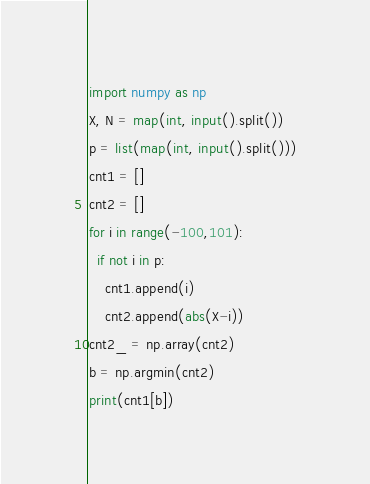<code> <loc_0><loc_0><loc_500><loc_500><_Python_>import numpy as np
X, N = map(int, input().split())
p = list(map(int, input().split()))
cnt1 = []
cnt2 = []
for i in range(-100,101):
  if not i in p:
    cnt1.append(i)
    cnt2.append(abs(X-i))
cnt2_ = np.array(cnt2)
b = np.argmin(cnt2)
print(cnt1[b])</code> 